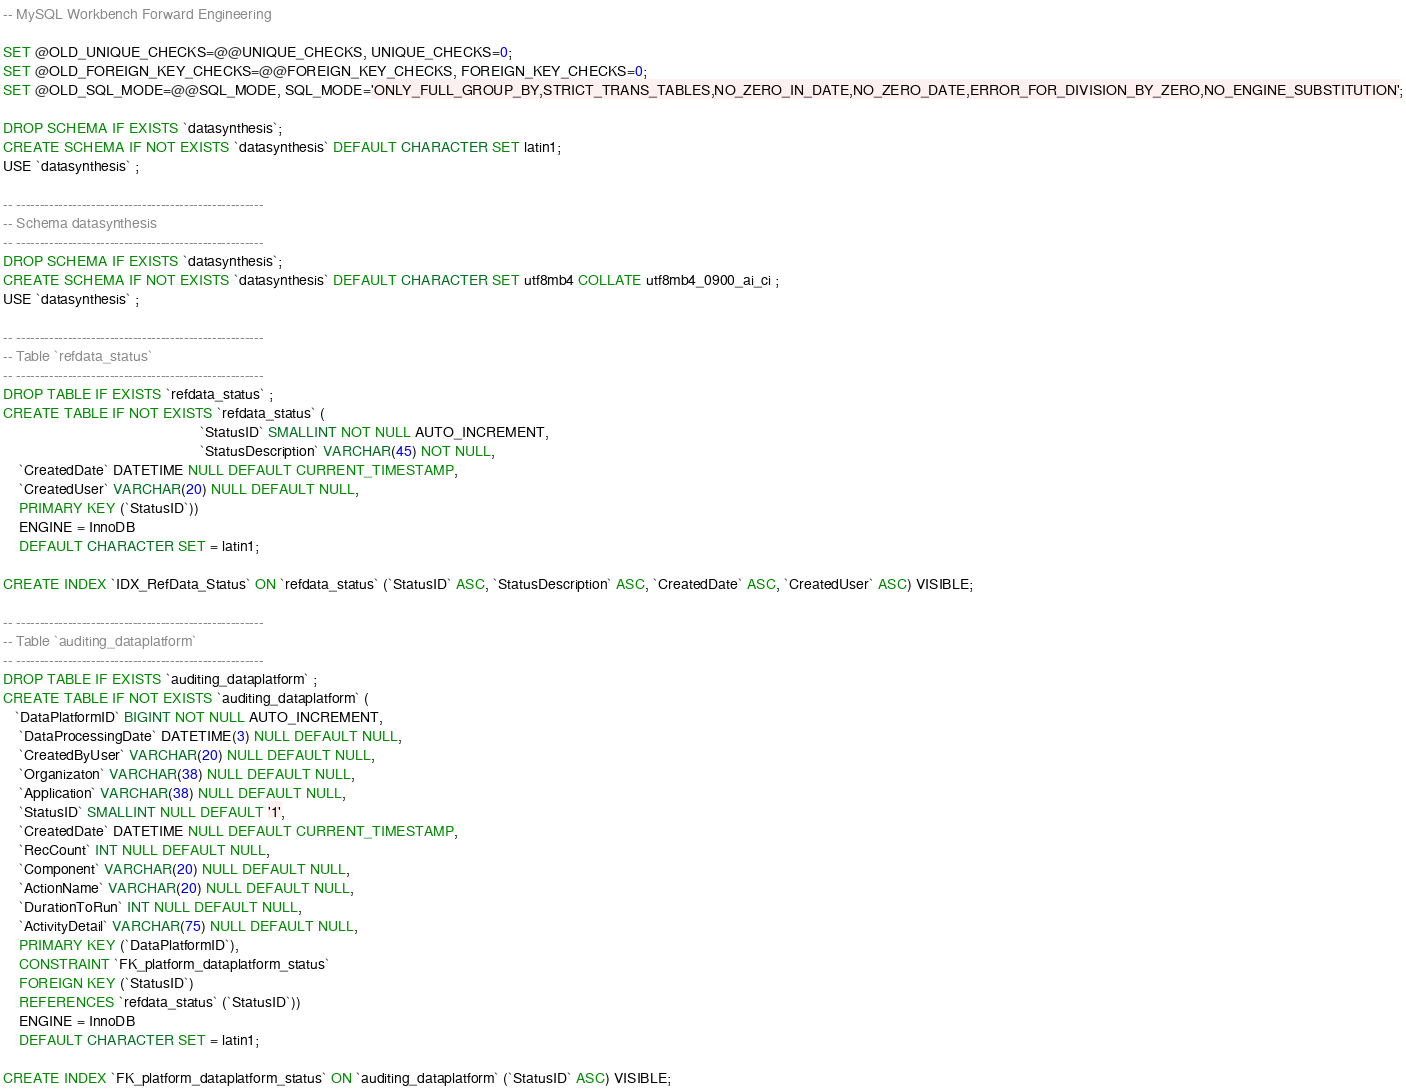Convert code to text. <code><loc_0><loc_0><loc_500><loc_500><_SQL_>-- MySQL Workbench Forward Engineering

SET @OLD_UNIQUE_CHECKS=@@UNIQUE_CHECKS, UNIQUE_CHECKS=0;
SET @OLD_FOREIGN_KEY_CHECKS=@@FOREIGN_KEY_CHECKS, FOREIGN_KEY_CHECKS=0;
SET @OLD_SQL_MODE=@@SQL_MODE, SQL_MODE='ONLY_FULL_GROUP_BY,STRICT_TRANS_TABLES,NO_ZERO_IN_DATE,NO_ZERO_DATE,ERROR_FOR_DIVISION_BY_ZERO,NO_ENGINE_SUBSTITUTION';

DROP SCHEMA IF EXISTS `datasynthesis`;
CREATE SCHEMA IF NOT EXISTS `datasynthesis` DEFAULT CHARACTER SET latin1;
USE `datasynthesis` ;

-- -----------------------------------------------------
-- Schema datasynthesis
-- -----------------------------------------------------
DROP SCHEMA IF EXISTS `datasynthesis`;
CREATE SCHEMA IF NOT EXISTS `datasynthesis` DEFAULT CHARACTER SET utf8mb4 COLLATE utf8mb4_0900_ai_ci ;
USE `datasynthesis` ;

-- -----------------------------------------------------
-- Table `refdata_status`
-- -----------------------------------------------------
DROP TABLE IF EXISTS `refdata_status` ;
CREATE TABLE IF NOT EXISTS `refdata_status` (
                                                `StatusID` SMALLINT NOT NULL AUTO_INCREMENT,
                                                `StatusDescription` VARCHAR(45) NOT NULL,
    `CreatedDate` DATETIME NULL DEFAULT CURRENT_TIMESTAMP,
    `CreatedUser` VARCHAR(20) NULL DEFAULT NULL,
    PRIMARY KEY (`StatusID`))
    ENGINE = InnoDB
    DEFAULT CHARACTER SET = latin1;

CREATE INDEX `IDX_RefData_Status` ON `refdata_status` (`StatusID` ASC, `StatusDescription` ASC, `CreatedDate` ASC, `CreatedUser` ASC) VISIBLE;

-- -----------------------------------------------------
-- Table `auditing_dataplatform`
-- -----------------------------------------------------
DROP TABLE IF EXISTS `auditing_dataplatform` ;
CREATE TABLE IF NOT EXISTS `auditing_dataplatform` (
   `DataPlatformID` BIGINT NOT NULL AUTO_INCREMENT,
    `DataProcessingDate` DATETIME(3) NULL DEFAULT NULL,
    `CreatedByUser` VARCHAR(20) NULL DEFAULT NULL,
    `Organizaton` VARCHAR(38) NULL DEFAULT NULL,
    `Application` VARCHAR(38) NULL DEFAULT NULL,
    `StatusID` SMALLINT NULL DEFAULT '1',
    `CreatedDate` DATETIME NULL DEFAULT CURRENT_TIMESTAMP,
    `RecCount` INT NULL DEFAULT NULL,
    `Component` VARCHAR(20) NULL DEFAULT NULL,
    `ActionName` VARCHAR(20) NULL DEFAULT NULL,
    `DurationToRun` INT NULL DEFAULT NULL,
    `ActivityDetail` VARCHAR(75) NULL DEFAULT NULL,
    PRIMARY KEY (`DataPlatformID`),
    CONSTRAINT `FK_platform_dataplatform_status`
    FOREIGN KEY (`StatusID`)
    REFERENCES `refdata_status` (`StatusID`))
    ENGINE = InnoDB
    DEFAULT CHARACTER SET = latin1;

CREATE INDEX `FK_platform_dataplatform_status` ON `auditing_dataplatform` (`StatusID` ASC) VISIBLE;
</code> 